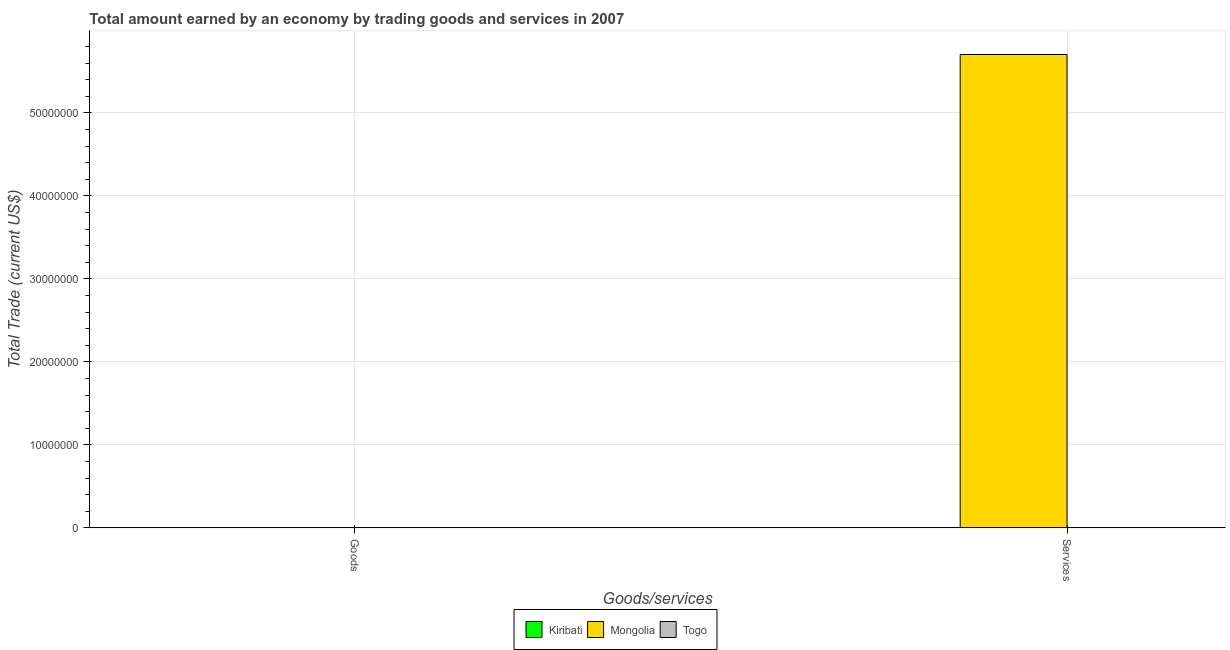How many bars are there on the 2nd tick from the right?
Give a very brief answer. 0. What is the label of the 1st group of bars from the left?
Keep it short and to the point. Goods. What is the amount earned by trading services in Kiribati?
Your answer should be very brief. 0. Across all countries, what is the maximum amount earned by trading services?
Make the answer very short. 5.70e+07. Across all countries, what is the minimum amount earned by trading services?
Provide a succinct answer. 0. In which country was the amount earned by trading services maximum?
Your answer should be compact. Mongolia. What is the total amount earned by trading goods in the graph?
Your answer should be compact. 0. What is the average amount earned by trading services per country?
Keep it short and to the point. 1.90e+07. In how many countries, is the amount earned by trading goods greater than 42000000 US$?
Your answer should be compact. 0. How many bars are there?
Your answer should be compact. 1. Are all the bars in the graph horizontal?
Provide a succinct answer. No. How many countries are there in the graph?
Make the answer very short. 3. What is the difference between two consecutive major ticks on the Y-axis?
Provide a succinct answer. 1.00e+07. Are the values on the major ticks of Y-axis written in scientific E-notation?
Give a very brief answer. No. Where does the legend appear in the graph?
Make the answer very short. Bottom center. How many legend labels are there?
Provide a succinct answer. 3. What is the title of the graph?
Give a very brief answer. Total amount earned by an economy by trading goods and services in 2007. What is the label or title of the X-axis?
Offer a terse response. Goods/services. What is the label or title of the Y-axis?
Make the answer very short. Total Trade (current US$). What is the Total Trade (current US$) in Mongolia in Goods?
Keep it short and to the point. 0. What is the Total Trade (current US$) of Togo in Goods?
Ensure brevity in your answer.  0. What is the Total Trade (current US$) in Kiribati in Services?
Your answer should be very brief. 0. What is the Total Trade (current US$) of Mongolia in Services?
Ensure brevity in your answer.  5.70e+07. Across all Goods/services, what is the maximum Total Trade (current US$) of Mongolia?
Give a very brief answer. 5.70e+07. Across all Goods/services, what is the minimum Total Trade (current US$) of Mongolia?
Make the answer very short. 0. What is the total Total Trade (current US$) of Mongolia in the graph?
Offer a terse response. 5.70e+07. What is the total Total Trade (current US$) of Togo in the graph?
Ensure brevity in your answer.  0. What is the average Total Trade (current US$) of Mongolia per Goods/services?
Give a very brief answer. 2.85e+07. What is the average Total Trade (current US$) in Togo per Goods/services?
Make the answer very short. 0. What is the difference between the highest and the lowest Total Trade (current US$) in Mongolia?
Your answer should be compact. 5.70e+07. 